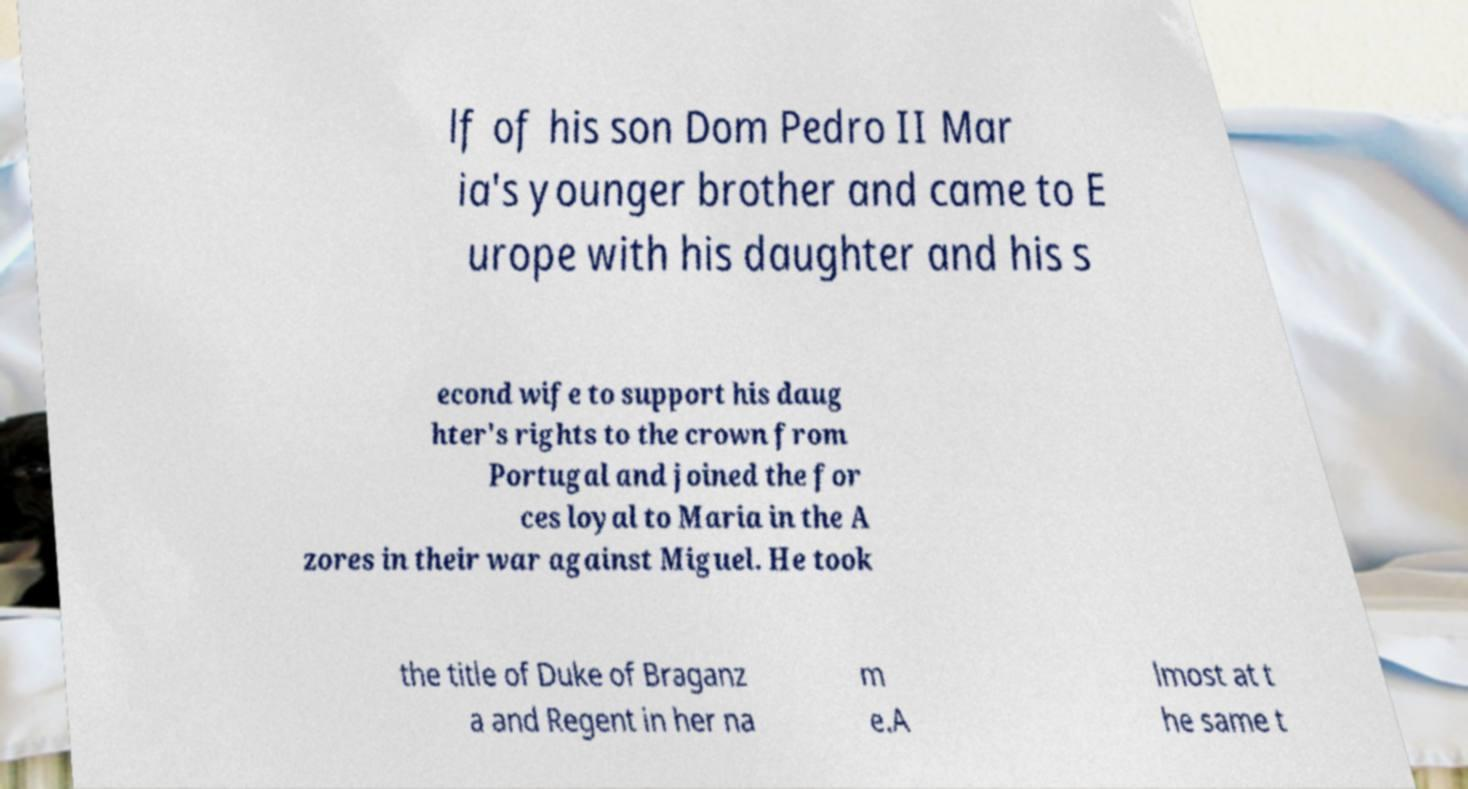Could you assist in decoding the text presented in this image and type it out clearly? lf of his son Dom Pedro II Mar ia's younger brother and came to E urope with his daughter and his s econd wife to support his daug hter's rights to the crown from Portugal and joined the for ces loyal to Maria in the A zores in their war against Miguel. He took the title of Duke of Braganz a and Regent in her na m e.A lmost at t he same t 